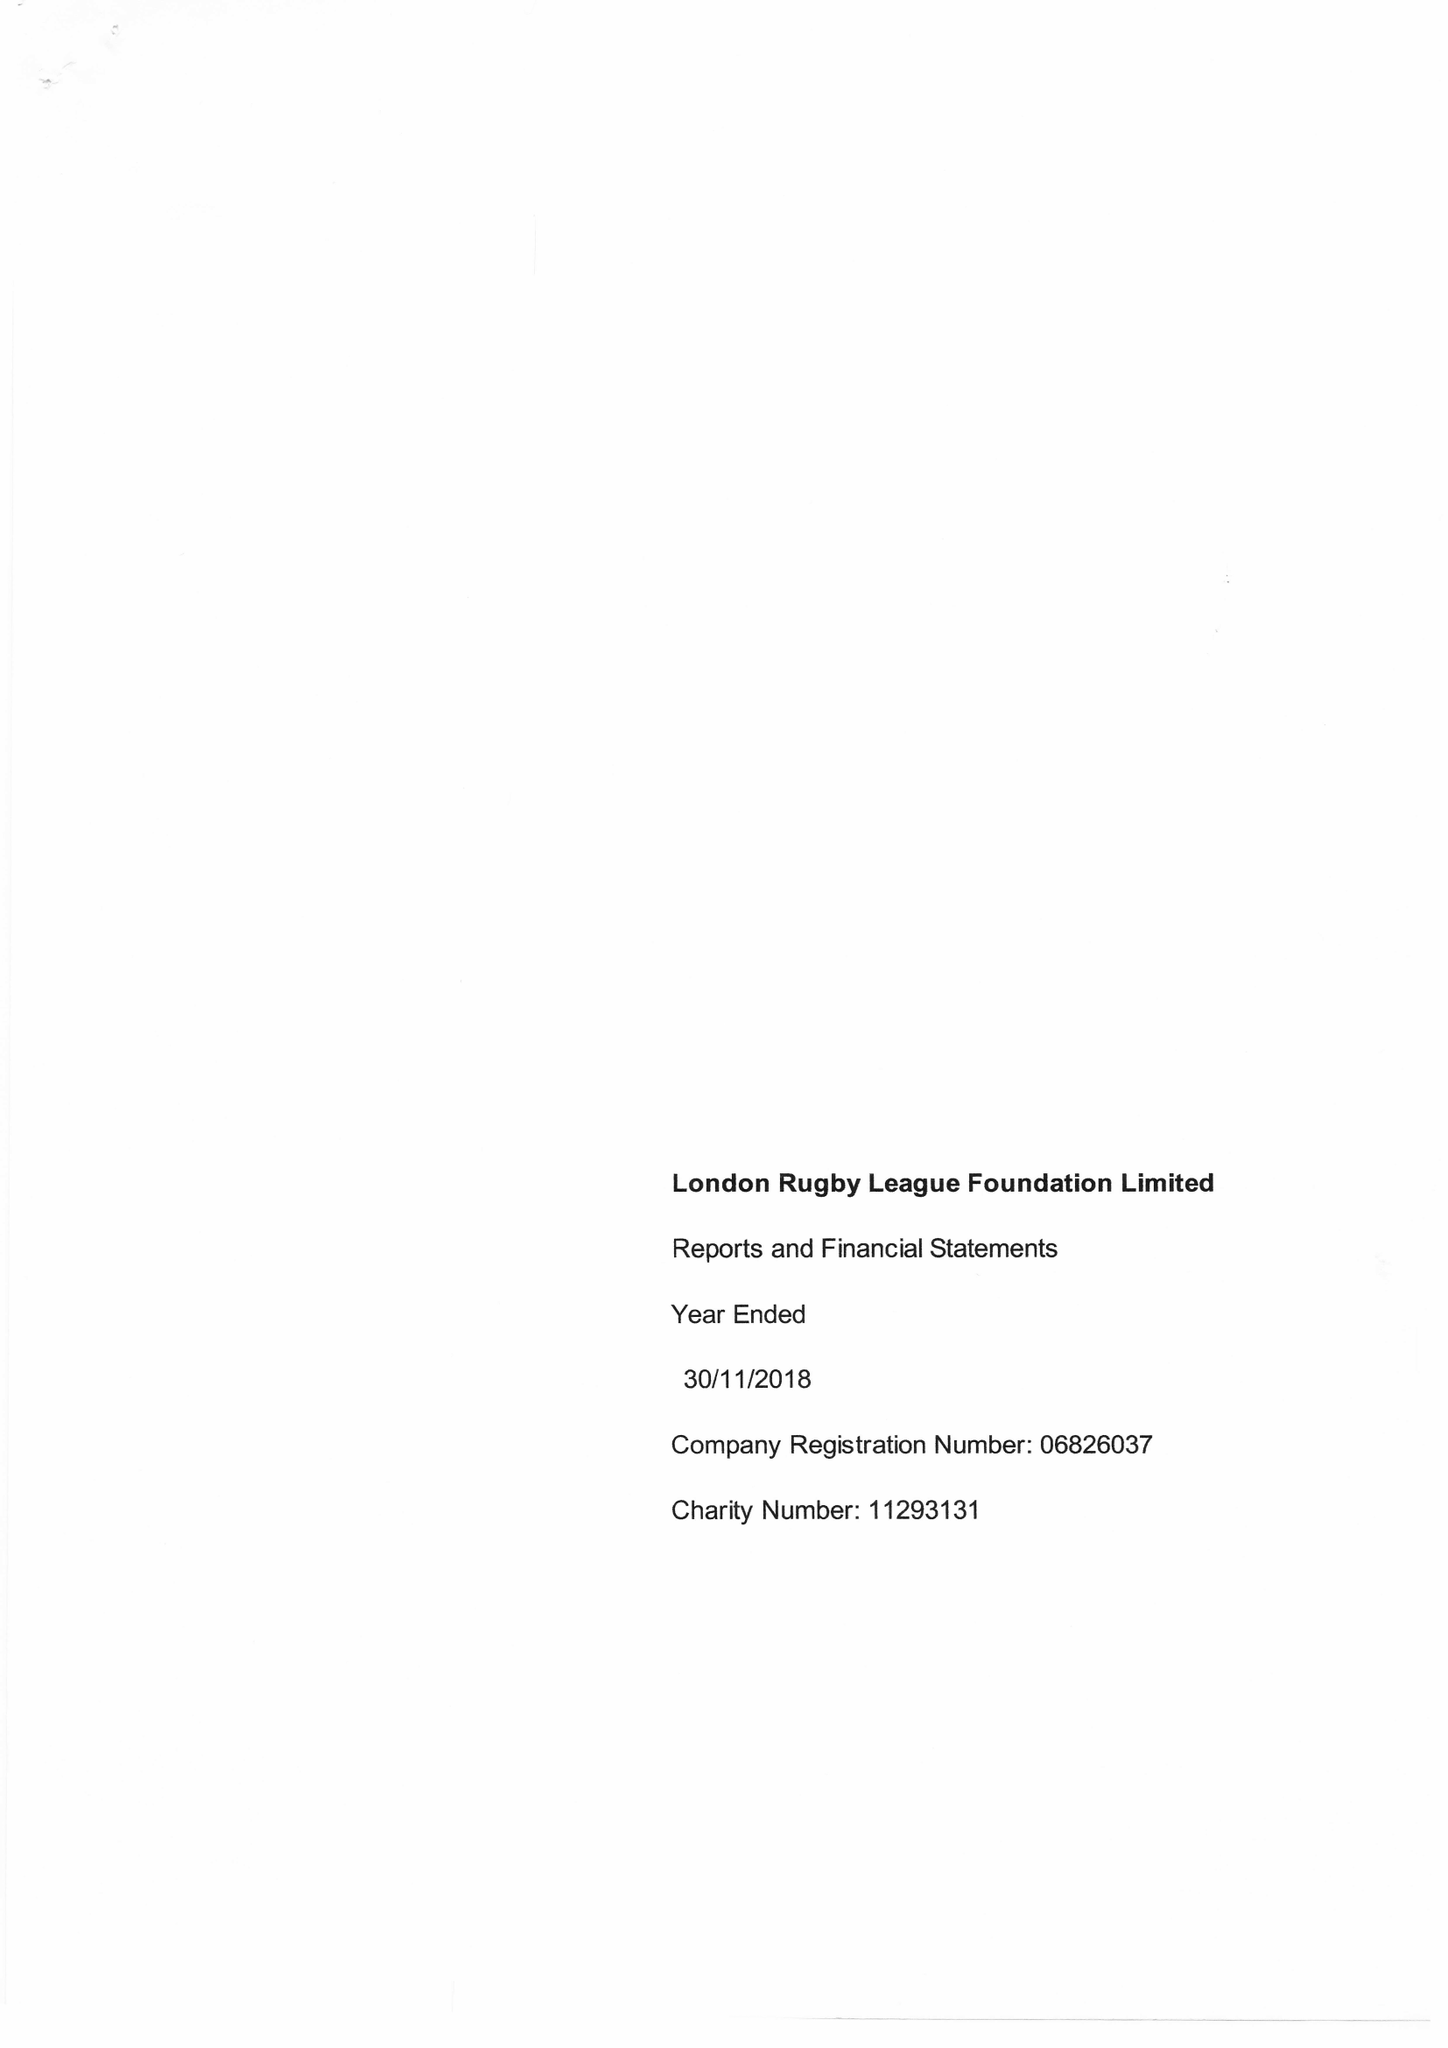What is the value for the charity_name?
Answer the question using a single word or phrase. London Rugby League Foundation Ltd. 